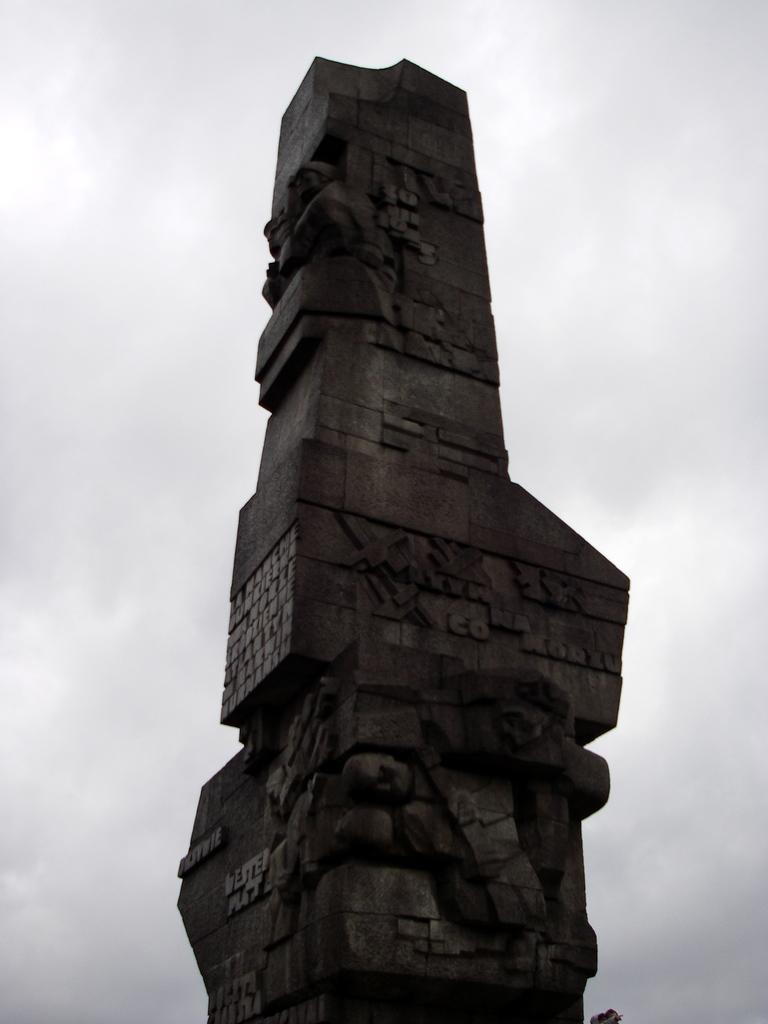What is the main structure located in the middle of the image? There is a stone tower in the middle of the image. What can be seen in the background of the image? There is a cloudy sky visible in the background of the image. Where is the maid holding the notebook in the image? There is no maid or notebook present in the image. 